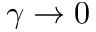Convert formula to latex. <formula><loc_0><loc_0><loc_500><loc_500>\gamma \to 0</formula> 